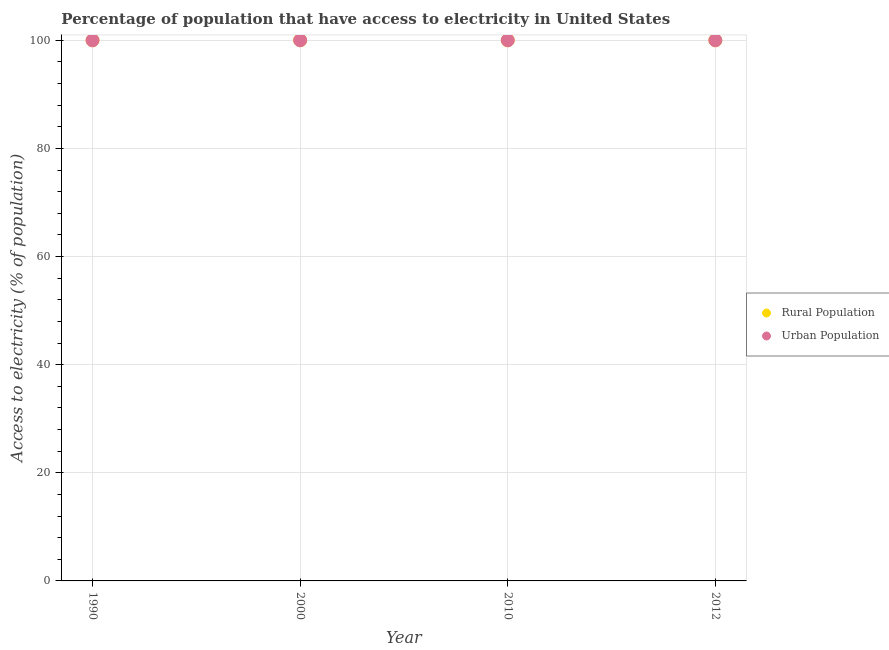Is the number of dotlines equal to the number of legend labels?
Ensure brevity in your answer.  Yes. What is the percentage of rural population having access to electricity in 2012?
Ensure brevity in your answer.  100. Across all years, what is the maximum percentage of rural population having access to electricity?
Offer a very short reply. 100. Across all years, what is the minimum percentage of rural population having access to electricity?
Offer a terse response. 100. What is the total percentage of urban population having access to electricity in the graph?
Give a very brief answer. 400. What is the difference between the percentage of urban population having access to electricity in 1990 and that in 2010?
Your response must be concise. 0. Is the percentage of urban population having access to electricity in 2010 less than that in 2012?
Offer a terse response. No. What is the difference between the highest and the second highest percentage of urban population having access to electricity?
Your response must be concise. 0. In how many years, is the percentage of rural population having access to electricity greater than the average percentage of rural population having access to electricity taken over all years?
Make the answer very short. 0. Is the percentage of rural population having access to electricity strictly less than the percentage of urban population having access to electricity over the years?
Your answer should be very brief. No. What is the difference between two consecutive major ticks on the Y-axis?
Make the answer very short. 20. Are the values on the major ticks of Y-axis written in scientific E-notation?
Provide a succinct answer. No. Does the graph contain any zero values?
Offer a very short reply. No. Where does the legend appear in the graph?
Give a very brief answer. Center right. How many legend labels are there?
Ensure brevity in your answer.  2. What is the title of the graph?
Keep it short and to the point. Percentage of population that have access to electricity in United States. Does "Under-5(male)" appear as one of the legend labels in the graph?
Offer a terse response. No. What is the label or title of the Y-axis?
Your answer should be very brief. Access to electricity (% of population). What is the Access to electricity (% of population) in Rural Population in 2010?
Provide a succinct answer. 100. What is the Access to electricity (% of population) of Rural Population in 2012?
Offer a terse response. 100. Across all years, what is the minimum Access to electricity (% of population) in Rural Population?
Provide a short and direct response. 100. Across all years, what is the minimum Access to electricity (% of population) of Urban Population?
Offer a terse response. 100. What is the total Access to electricity (% of population) in Urban Population in the graph?
Keep it short and to the point. 400. What is the difference between the Access to electricity (% of population) of Urban Population in 1990 and that in 2000?
Your response must be concise. 0. What is the difference between the Access to electricity (% of population) in Urban Population in 1990 and that in 2010?
Keep it short and to the point. 0. What is the difference between the Access to electricity (% of population) of Urban Population in 1990 and that in 2012?
Provide a short and direct response. 0. What is the difference between the Access to electricity (% of population) of Urban Population in 2000 and that in 2010?
Ensure brevity in your answer.  0. What is the difference between the Access to electricity (% of population) of Rural Population in 2010 and that in 2012?
Your response must be concise. 0. What is the difference between the Access to electricity (% of population) of Rural Population in 1990 and the Access to electricity (% of population) of Urban Population in 2000?
Keep it short and to the point. 0. What is the difference between the Access to electricity (% of population) in Rural Population in 1990 and the Access to electricity (% of population) in Urban Population in 2010?
Give a very brief answer. 0. What is the difference between the Access to electricity (% of population) of Rural Population in 1990 and the Access to electricity (% of population) of Urban Population in 2012?
Keep it short and to the point. 0. What is the difference between the Access to electricity (% of population) of Rural Population in 2000 and the Access to electricity (% of population) of Urban Population in 2010?
Ensure brevity in your answer.  0. What is the difference between the Access to electricity (% of population) of Rural Population in 2000 and the Access to electricity (% of population) of Urban Population in 2012?
Your response must be concise. 0. What is the average Access to electricity (% of population) of Rural Population per year?
Your answer should be very brief. 100. In the year 2012, what is the difference between the Access to electricity (% of population) in Rural Population and Access to electricity (% of population) in Urban Population?
Offer a terse response. 0. What is the ratio of the Access to electricity (% of population) of Urban Population in 1990 to that in 2012?
Keep it short and to the point. 1. What is the ratio of the Access to electricity (% of population) in Urban Population in 2000 to that in 2010?
Your answer should be very brief. 1. What is the ratio of the Access to electricity (% of population) of Urban Population in 2010 to that in 2012?
Your answer should be very brief. 1. What is the difference between the highest and the second highest Access to electricity (% of population) of Rural Population?
Offer a very short reply. 0. What is the difference between the highest and the second highest Access to electricity (% of population) in Urban Population?
Keep it short and to the point. 0. What is the difference between the highest and the lowest Access to electricity (% of population) in Rural Population?
Offer a very short reply. 0. 